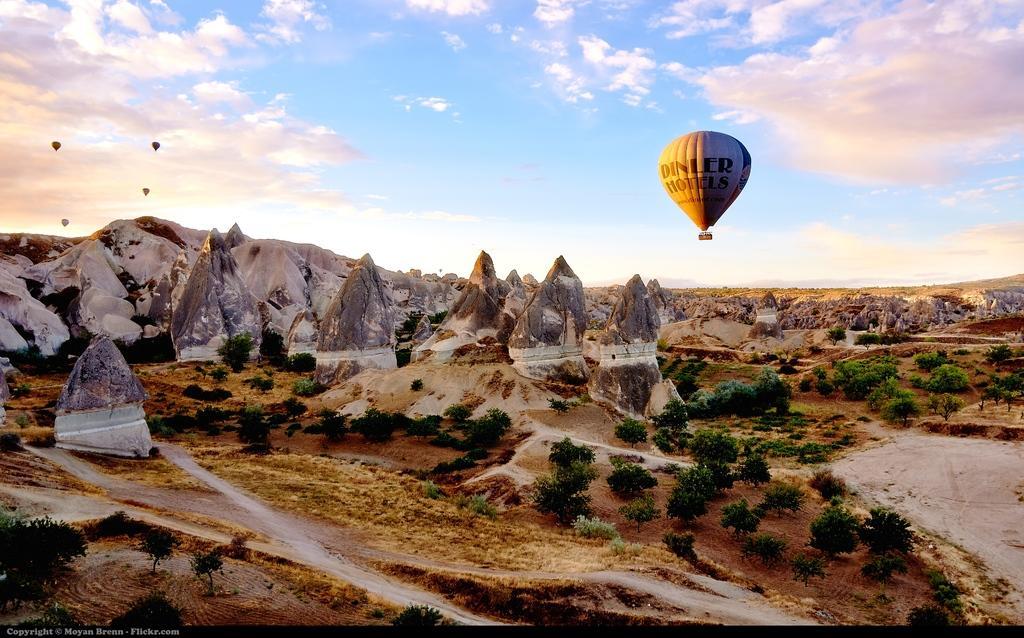In one or two sentences, can you explain what this image depicts? There are five hot air balloon in the sky. There are many big stones and trees. 